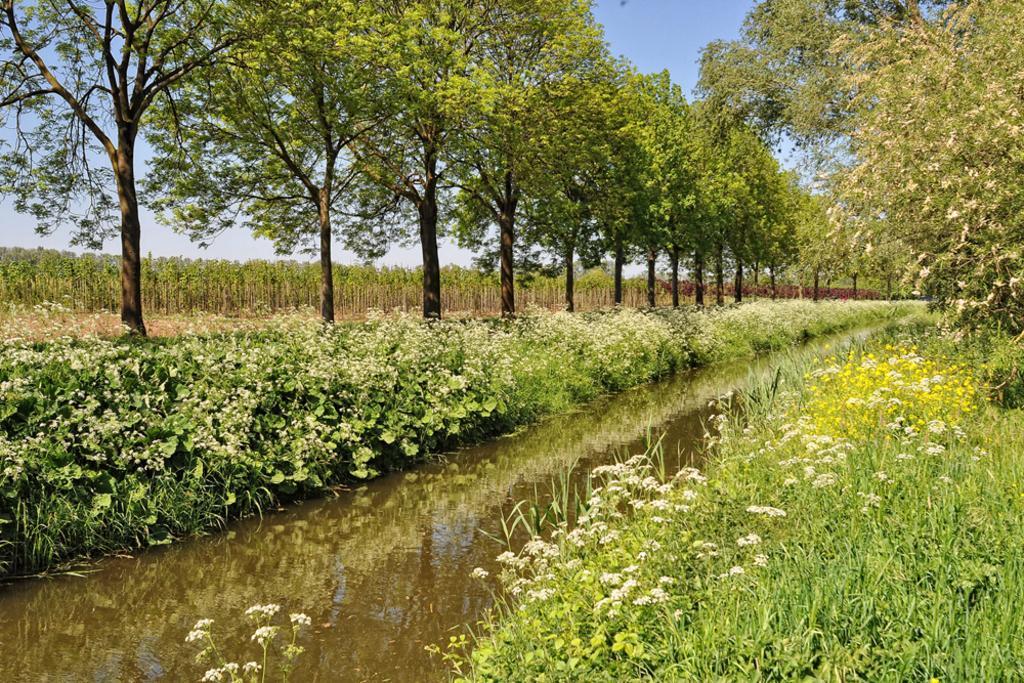Could you give a brief overview of what you see in this image? In this picture we can see flowers, grass and water. On the right we can see many trees. On the left background we can see farmland. On the top there is a sky. 